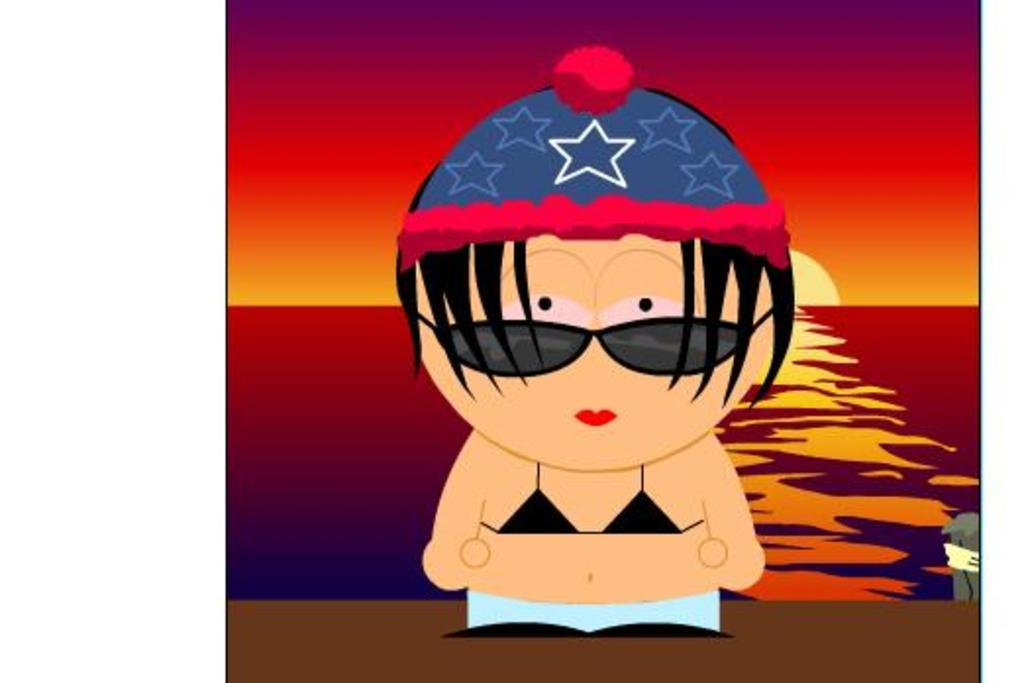What type of image is being described? The image is animated. Can you describe the characters or subjects in the image? There is a woman in the image. What can be seen in the background of the image? Sky, the sun, and water are visible in the background of the image. What type of fruit is the woman holding in the image? There is no fruit visible in the image, and the woman is not holding anything. Can you tell me how many pickles are floating in the water in the image? There are no pickles present in the image; only the woman and the background elements are visible. 